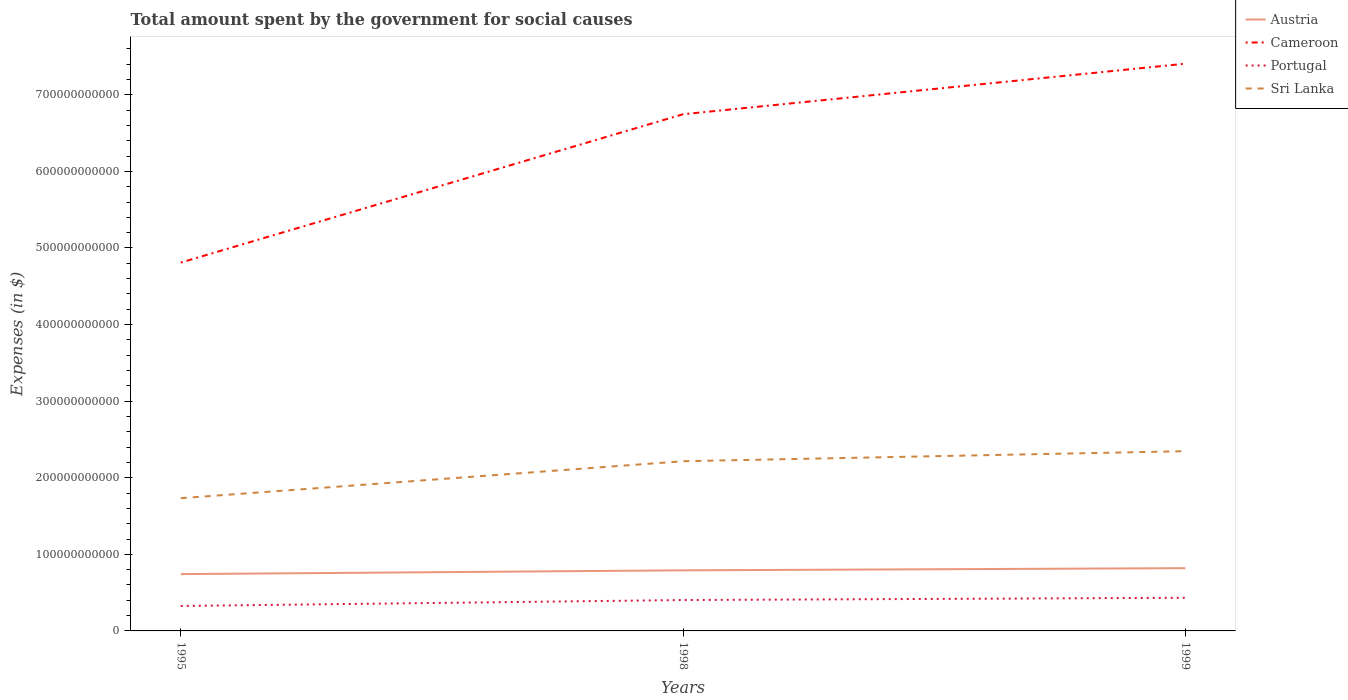Is the number of lines equal to the number of legend labels?
Provide a succinct answer. Yes. Across all years, what is the maximum amount spent for social causes by the government in Cameroon?
Keep it short and to the point. 4.81e+11. What is the total amount spent for social causes by the government in Austria in the graph?
Make the answer very short. -7.77e+09. What is the difference between the highest and the second highest amount spent for social causes by the government in Cameroon?
Provide a short and direct response. 2.60e+11. What is the difference between the highest and the lowest amount spent for social causes by the government in Cameroon?
Your response must be concise. 2. How many lines are there?
Offer a terse response. 4. How many years are there in the graph?
Give a very brief answer. 3. What is the difference between two consecutive major ticks on the Y-axis?
Keep it short and to the point. 1.00e+11. Are the values on the major ticks of Y-axis written in scientific E-notation?
Make the answer very short. No. How many legend labels are there?
Make the answer very short. 4. How are the legend labels stacked?
Give a very brief answer. Vertical. What is the title of the graph?
Provide a succinct answer. Total amount spent by the government for social causes. Does "Czech Republic" appear as one of the legend labels in the graph?
Offer a terse response. No. What is the label or title of the Y-axis?
Your answer should be compact. Expenses (in $). What is the Expenses (in $) of Austria in 1995?
Provide a short and direct response. 7.42e+1. What is the Expenses (in $) of Cameroon in 1995?
Provide a succinct answer. 4.81e+11. What is the Expenses (in $) of Portugal in 1995?
Your answer should be compact. 3.26e+1. What is the Expenses (in $) in Sri Lanka in 1995?
Offer a terse response. 1.73e+11. What is the Expenses (in $) of Austria in 1998?
Keep it short and to the point. 7.91e+1. What is the Expenses (in $) in Cameroon in 1998?
Keep it short and to the point. 6.75e+11. What is the Expenses (in $) of Portugal in 1998?
Your response must be concise. 4.03e+1. What is the Expenses (in $) in Sri Lanka in 1998?
Your answer should be very brief. 2.22e+11. What is the Expenses (in $) in Austria in 1999?
Make the answer very short. 8.19e+1. What is the Expenses (in $) of Cameroon in 1999?
Keep it short and to the point. 7.41e+11. What is the Expenses (in $) in Portugal in 1999?
Keep it short and to the point. 4.33e+1. What is the Expenses (in $) in Sri Lanka in 1999?
Give a very brief answer. 2.35e+11. Across all years, what is the maximum Expenses (in $) of Austria?
Provide a short and direct response. 8.19e+1. Across all years, what is the maximum Expenses (in $) in Cameroon?
Your answer should be compact. 7.41e+11. Across all years, what is the maximum Expenses (in $) of Portugal?
Offer a very short reply. 4.33e+1. Across all years, what is the maximum Expenses (in $) in Sri Lanka?
Your answer should be compact. 2.35e+11. Across all years, what is the minimum Expenses (in $) in Austria?
Provide a succinct answer. 7.42e+1. Across all years, what is the minimum Expenses (in $) of Cameroon?
Make the answer very short. 4.81e+11. Across all years, what is the minimum Expenses (in $) in Portugal?
Your answer should be compact. 3.26e+1. Across all years, what is the minimum Expenses (in $) of Sri Lanka?
Give a very brief answer. 1.73e+11. What is the total Expenses (in $) of Austria in the graph?
Provide a short and direct response. 2.35e+11. What is the total Expenses (in $) in Cameroon in the graph?
Give a very brief answer. 1.90e+12. What is the total Expenses (in $) in Portugal in the graph?
Your answer should be compact. 1.16e+11. What is the total Expenses (in $) in Sri Lanka in the graph?
Offer a terse response. 6.30e+11. What is the difference between the Expenses (in $) of Austria in 1995 and that in 1998?
Your answer should be compact. -4.95e+09. What is the difference between the Expenses (in $) of Cameroon in 1995 and that in 1998?
Your answer should be very brief. -1.94e+11. What is the difference between the Expenses (in $) of Portugal in 1995 and that in 1998?
Your answer should be compact. -7.75e+09. What is the difference between the Expenses (in $) in Sri Lanka in 1995 and that in 1998?
Give a very brief answer. -4.83e+1. What is the difference between the Expenses (in $) of Austria in 1995 and that in 1999?
Give a very brief answer. -7.77e+09. What is the difference between the Expenses (in $) of Cameroon in 1995 and that in 1999?
Your answer should be compact. -2.60e+11. What is the difference between the Expenses (in $) in Portugal in 1995 and that in 1999?
Provide a short and direct response. -1.07e+1. What is the difference between the Expenses (in $) in Sri Lanka in 1995 and that in 1999?
Offer a very short reply. -6.14e+1. What is the difference between the Expenses (in $) in Austria in 1998 and that in 1999?
Ensure brevity in your answer.  -2.82e+09. What is the difference between the Expenses (in $) in Cameroon in 1998 and that in 1999?
Make the answer very short. -6.60e+1. What is the difference between the Expenses (in $) in Portugal in 1998 and that in 1999?
Offer a very short reply. -2.96e+09. What is the difference between the Expenses (in $) in Sri Lanka in 1998 and that in 1999?
Provide a succinct answer. -1.31e+1. What is the difference between the Expenses (in $) in Austria in 1995 and the Expenses (in $) in Cameroon in 1998?
Give a very brief answer. -6.00e+11. What is the difference between the Expenses (in $) of Austria in 1995 and the Expenses (in $) of Portugal in 1998?
Your answer should be very brief. 3.38e+1. What is the difference between the Expenses (in $) of Austria in 1995 and the Expenses (in $) of Sri Lanka in 1998?
Provide a short and direct response. -1.47e+11. What is the difference between the Expenses (in $) of Cameroon in 1995 and the Expenses (in $) of Portugal in 1998?
Your answer should be very brief. 4.41e+11. What is the difference between the Expenses (in $) of Cameroon in 1995 and the Expenses (in $) of Sri Lanka in 1998?
Provide a short and direct response. 2.59e+11. What is the difference between the Expenses (in $) in Portugal in 1995 and the Expenses (in $) in Sri Lanka in 1998?
Your answer should be very brief. -1.89e+11. What is the difference between the Expenses (in $) of Austria in 1995 and the Expenses (in $) of Cameroon in 1999?
Your answer should be compact. -6.66e+11. What is the difference between the Expenses (in $) in Austria in 1995 and the Expenses (in $) in Portugal in 1999?
Offer a very short reply. 3.09e+1. What is the difference between the Expenses (in $) of Austria in 1995 and the Expenses (in $) of Sri Lanka in 1999?
Your answer should be very brief. -1.61e+11. What is the difference between the Expenses (in $) in Cameroon in 1995 and the Expenses (in $) in Portugal in 1999?
Your answer should be very brief. 4.38e+11. What is the difference between the Expenses (in $) of Cameroon in 1995 and the Expenses (in $) of Sri Lanka in 1999?
Make the answer very short. 2.46e+11. What is the difference between the Expenses (in $) of Portugal in 1995 and the Expenses (in $) of Sri Lanka in 1999?
Provide a succinct answer. -2.02e+11. What is the difference between the Expenses (in $) in Austria in 1998 and the Expenses (in $) in Cameroon in 1999?
Offer a terse response. -6.61e+11. What is the difference between the Expenses (in $) of Austria in 1998 and the Expenses (in $) of Portugal in 1999?
Give a very brief answer. 3.58e+1. What is the difference between the Expenses (in $) of Austria in 1998 and the Expenses (in $) of Sri Lanka in 1999?
Provide a succinct answer. -1.56e+11. What is the difference between the Expenses (in $) in Cameroon in 1998 and the Expenses (in $) in Portugal in 1999?
Give a very brief answer. 6.31e+11. What is the difference between the Expenses (in $) in Cameroon in 1998 and the Expenses (in $) in Sri Lanka in 1999?
Keep it short and to the point. 4.40e+11. What is the difference between the Expenses (in $) in Portugal in 1998 and the Expenses (in $) in Sri Lanka in 1999?
Your answer should be compact. -1.94e+11. What is the average Expenses (in $) of Austria per year?
Provide a succinct answer. 7.84e+1. What is the average Expenses (in $) of Cameroon per year?
Your answer should be very brief. 6.32e+11. What is the average Expenses (in $) of Portugal per year?
Offer a very short reply. 3.87e+1. What is the average Expenses (in $) of Sri Lanka per year?
Provide a short and direct response. 2.10e+11. In the year 1995, what is the difference between the Expenses (in $) of Austria and Expenses (in $) of Cameroon?
Give a very brief answer. -4.07e+11. In the year 1995, what is the difference between the Expenses (in $) in Austria and Expenses (in $) in Portugal?
Your response must be concise. 4.16e+1. In the year 1995, what is the difference between the Expenses (in $) in Austria and Expenses (in $) in Sri Lanka?
Ensure brevity in your answer.  -9.91e+1. In the year 1995, what is the difference between the Expenses (in $) of Cameroon and Expenses (in $) of Portugal?
Provide a short and direct response. 4.48e+11. In the year 1995, what is the difference between the Expenses (in $) in Cameroon and Expenses (in $) in Sri Lanka?
Provide a succinct answer. 3.08e+11. In the year 1995, what is the difference between the Expenses (in $) in Portugal and Expenses (in $) in Sri Lanka?
Ensure brevity in your answer.  -1.41e+11. In the year 1998, what is the difference between the Expenses (in $) of Austria and Expenses (in $) of Cameroon?
Your answer should be very brief. -5.95e+11. In the year 1998, what is the difference between the Expenses (in $) in Austria and Expenses (in $) in Portugal?
Offer a very short reply. 3.88e+1. In the year 1998, what is the difference between the Expenses (in $) of Austria and Expenses (in $) of Sri Lanka?
Your answer should be compact. -1.42e+11. In the year 1998, what is the difference between the Expenses (in $) of Cameroon and Expenses (in $) of Portugal?
Offer a terse response. 6.34e+11. In the year 1998, what is the difference between the Expenses (in $) in Cameroon and Expenses (in $) in Sri Lanka?
Give a very brief answer. 4.53e+11. In the year 1998, what is the difference between the Expenses (in $) of Portugal and Expenses (in $) of Sri Lanka?
Ensure brevity in your answer.  -1.81e+11. In the year 1999, what is the difference between the Expenses (in $) in Austria and Expenses (in $) in Cameroon?
Your answer should be compact. -6.59e+11. In the year 1999, what is the difference between the Expenses (in $) of Austria and Expenses (in $) of Portugal?
Your answer should be compact. 3.87e+1. In the year 1999, what is the difference between the Expenses (in $) of Austria and Expenses (in $) of Sri Lanka?
Provide a succinct answer. -1.53e+11. In the year 1999, what is the difference between the Expenses (in $) of Cameroon and Expenses (in $) of Portugal?
Give a very brief answer. 6.97e+11. In the year 1999, what is the difference between the Expenses (in $) of Cameroon and Expenses (in $) of Sri Lanka?
Provide a short and direct response. 5.06e+11. In the year 1999, what is the difference between the Expenses (in $) of Portugal and Expenses (in $) of Sri Lanka?
Give a very brief answer. -1.91e+11. What is the ratio of the Expenses (in $) in Austria in 1995 to that in 1998?
Ensure brevity in your answer.  0.94. What is the ratio of the Expenses (in $) in Cameroon in 1995 to that in 1998?
Offer a very short reply. 0.71. What is the ratio of the Expenses (in $) of Portugal in 1995 to that in 1998?
Your answer should be compact. 0.81. What is the ratio of the Expenses (in $) of Sri Lanka in 1995 to that in 1998?
Give a very brief answer. 0.78. What is the ratio of the Expenses (in $) in Austria in 1995 to that in 1999?
Provide a short and direct response. 0.91. What is the ratio of the Expenses (in $) in Cameroon in 1995 to that in 1999?
Make the answer very short. 0.65. What is the ratio of the Expenses (in $) of Portugal in 1995 to that in 1999?
Give a very brief answer. 0.75. What is the ratio of the Expenses (in $) of Sri Lanka in 1995 to that in 1999?
Provide a succinct answer. 0.74. What is the ratio of the Expenses (in $) in Austria in 1998 to that in 1999?
Offer a terse response. 0.97. What is the ratio of the Expenses (in $) of Cameroon in 1998 to that in 1999?
Your answer should be compact. 0.91. What is the ratio of the Expenses (in $) in Portugal in 1998 to that in 1999?
Your answer should be compact. 0.93. What is the ratio of the Expenses (in $) of Sri Lanka in 1998 to that in 1999?
Provide a short and direct response. 0.94. What is the difference between the highest and the second highest Expenses (in $) of Austria?
Keep it short and to the point. 2.82e+09. What is the difference between the highest and the second highest Expenses (in $) of Cameroon?
Your response must be concise. 6.60e+1. What is the difference between the highest and the second highest Expenses (in $) in Portugal?
Keep it short and to the point. 2.96e+09. What is the difference between the highest and the second highest Expenses (in $) of Sri Lanka?
Offer a terse response. 1.31e+1. What is the difference between the highest and the lowest Expenses (in $) in Austria?
Provide a succinct answer. 7.77e+09. What is the difference between the highest and the lowest Expenses (in $) of Cameroon?
Offer a very short reply. 2.60e+11. What is the difference between the highest and the lowest Expenses (in $) of Portugal?
Your answer should be compact. 1.07e+1. What is the difference between the highest and the lowest Expenses (in $) in Sri Lanka?
Provide a short and direct response. 6.14e+1. 